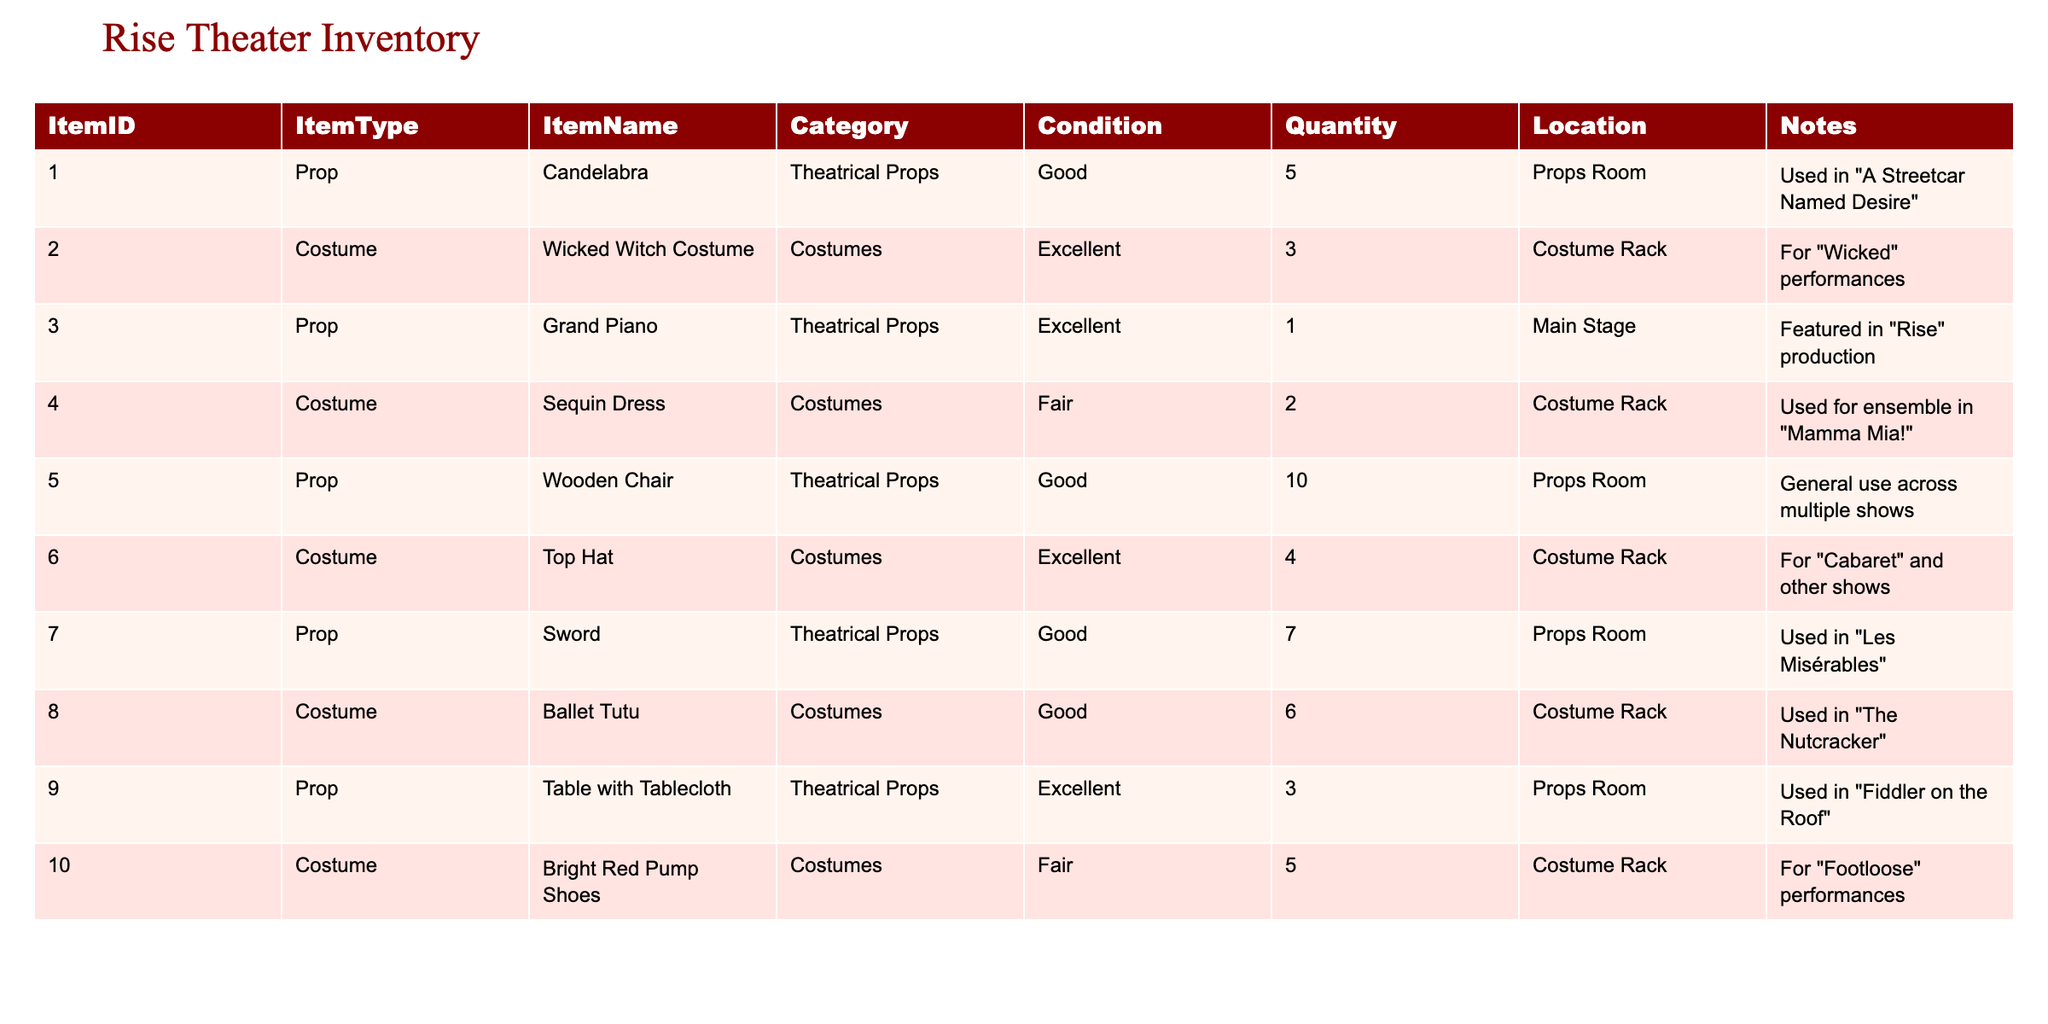What is the total quantity of "Costume" items in the inventory? The table lists three costumes with quantities: Wicked Witch Costume (3), Sequin Dress (2), and Top Hat (4), totaling 3 + 2 + 4 = 9.
Answer: 9 How many items are in "Good" condition? In the table, the items in "Good" condition are: Candelabra (5), Wooden Chair (10), Sword (7), Ballet Tutu (6). Adding these gives 5 + 10 + 7 + 6 = 28.
Answer: 28 Is there a Grand Piano in the inventory? Yes, the table shows that there is one Grand Piano listed under the props.
Answer: Yes Which costume has the lowest condition rating? The Sequin Dress and Bright Red Pump Shoes are both rated as "Fair", which is the lowest condition rating on the table.
Answer: Sequin Dress and Bright Red Pump Shoes How many more "Theatrical Props" are there than "Costumes" in total? The table lists a total of 7 theatrical props (5 + 1 + 10 + 7 + 3) and 6 costumes (3 + 2 + 4 + 5). The difference is 7 - 6 = 1.
Answer: 1 What items are currently stored in the "Props Room"? The Props Room contains the Candelabra (5), Wooden Chair (10), Sword (7), and Table with Tablecloth (3). Thus, there are 4 items in total stored there.
Answer: 4 items Which category has the highest quantity of items? The Props category has a total of 25 items (Candelabra: 5, Wooden Chair: 10, Sword: 7, Table with Tablecloth: 3). The Costume category has 16 items (3 + 2 + 4 + 5). Hence, Theatrical Props have a higher quantity.
Answer: Theatrical Props Are there any items used in "Rise"? Yes, the Grand Piano is noted to be featured in the "Rise" production.
Answer: Yes How many items are in "Excellent" condition? The items in "Excellent" condition are the Wicked Witch Costume (3), Grand Piano (1), and Top Hat (4). Thus, there are 3 + 1 + 4 = 8 items in this condition.
Answer: 8 